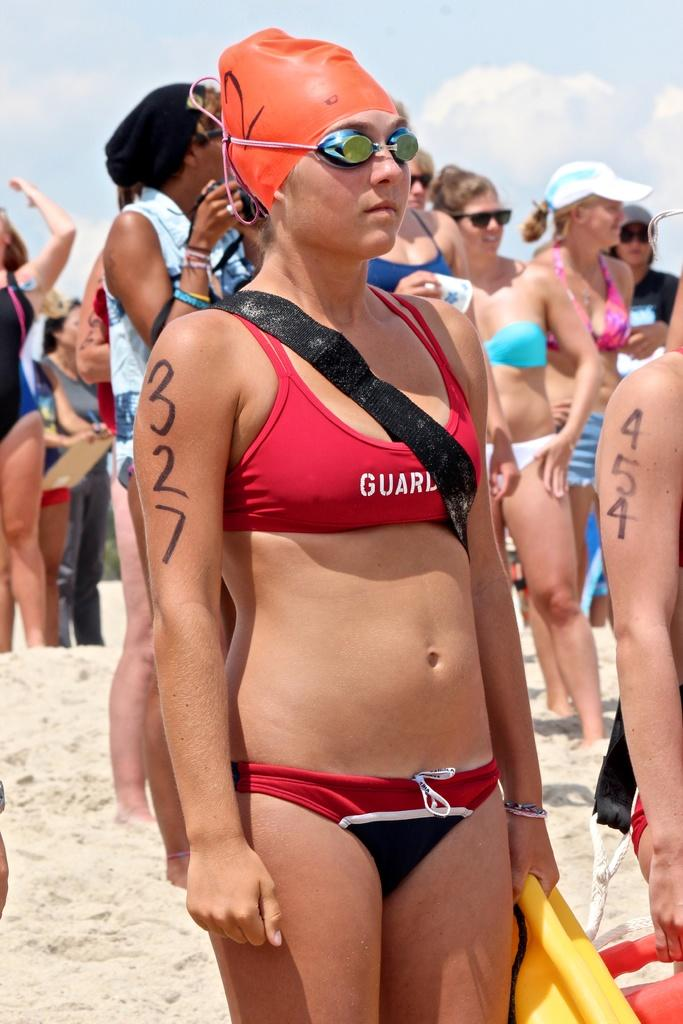<image>
Offer a succinct explanation of the picture presented. A woman in a two piece bathing suit has the number 327 on her arm. 